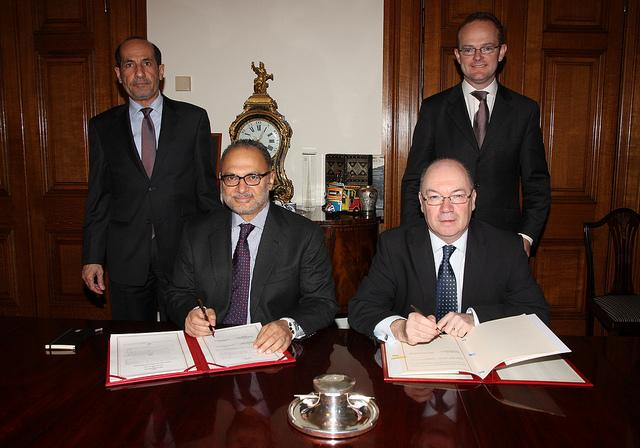What type of event is this? Please explain your reasoning. meeting. The men are in business attire. 